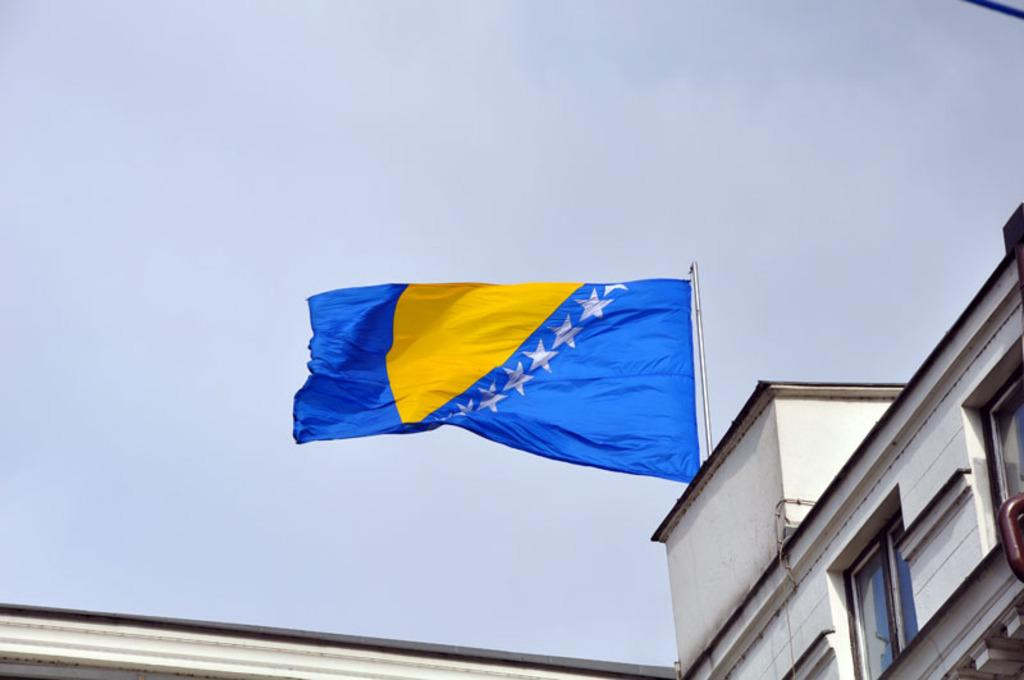What structure is the main subject of the image? There is a building in the image. What is located on top of the building? There is a flag on top of the building. What can be seen in the background of the image? The sky is visible in the background of the image. Where is the table located in the image? There is no table present in the image. 